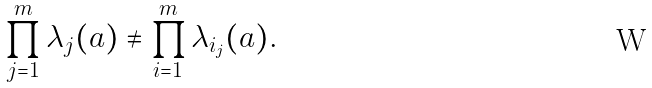Convert formula to latex. <formula><loc_0><loc_0><loc_500><loc_500>\prod _ { j = 1 } ^ { m } \lambda _ { j } ( a ) \neq \prod _ { i = 1 } ^ { m } \lambda _ { i _ { j } } ( a ) .</formula> 